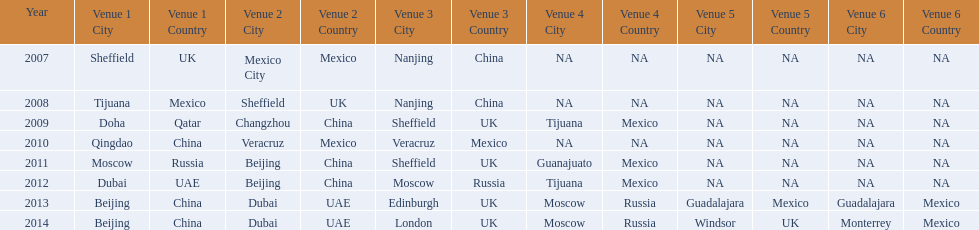Which year is previous to 2011 2010. 